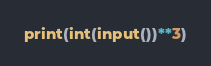Convert code to text. <code><loc_0><loc_0><loc_500><loc_500><_Python_>print(int(input())**3)</code> 